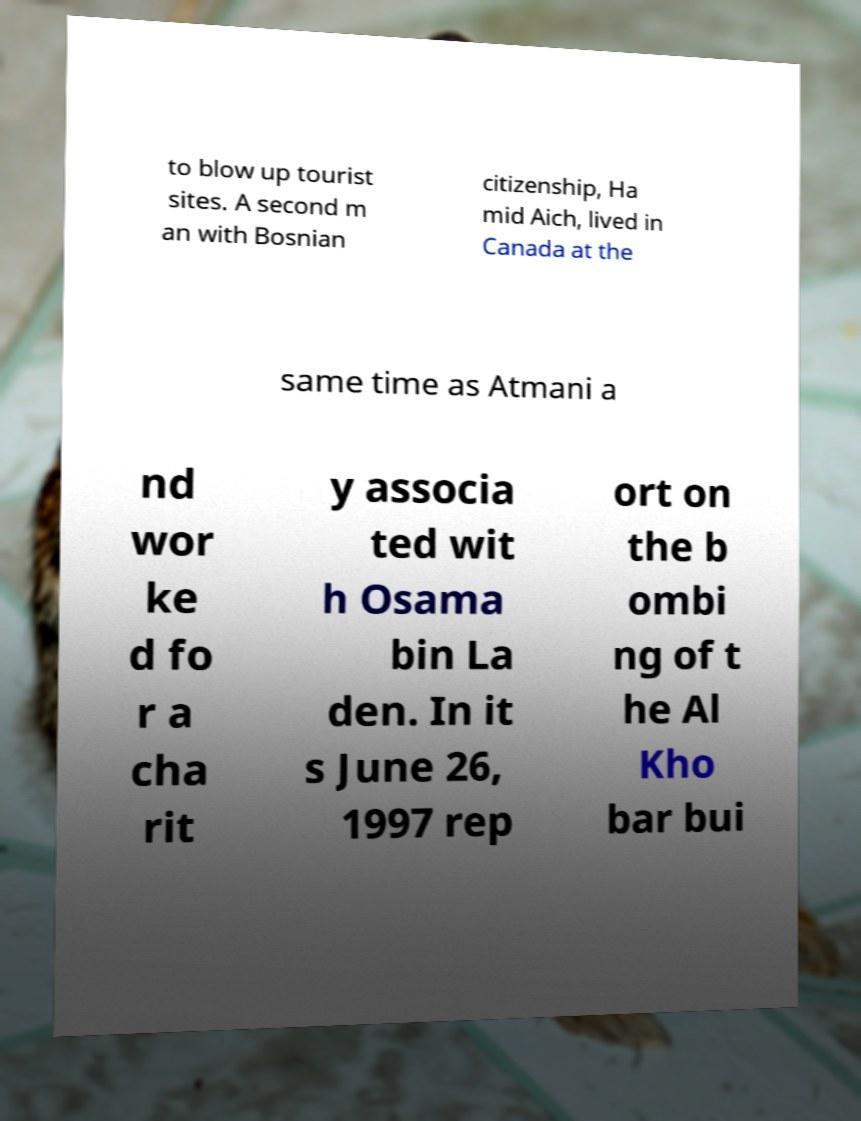There's text embedded in this image that I need extracted. Can you transcribe it verbatim? to blow up tourist sites. A second m an with Bosnian citizenship, Ha mid Aich, lived in Canada at the same time as Atmani a nd wor ke d fo r a cha rit y associa ted wit h Osama bin La den. In it s June 26, 1997 rep ort on the b ombi ng of t he Al Kho bar bui 